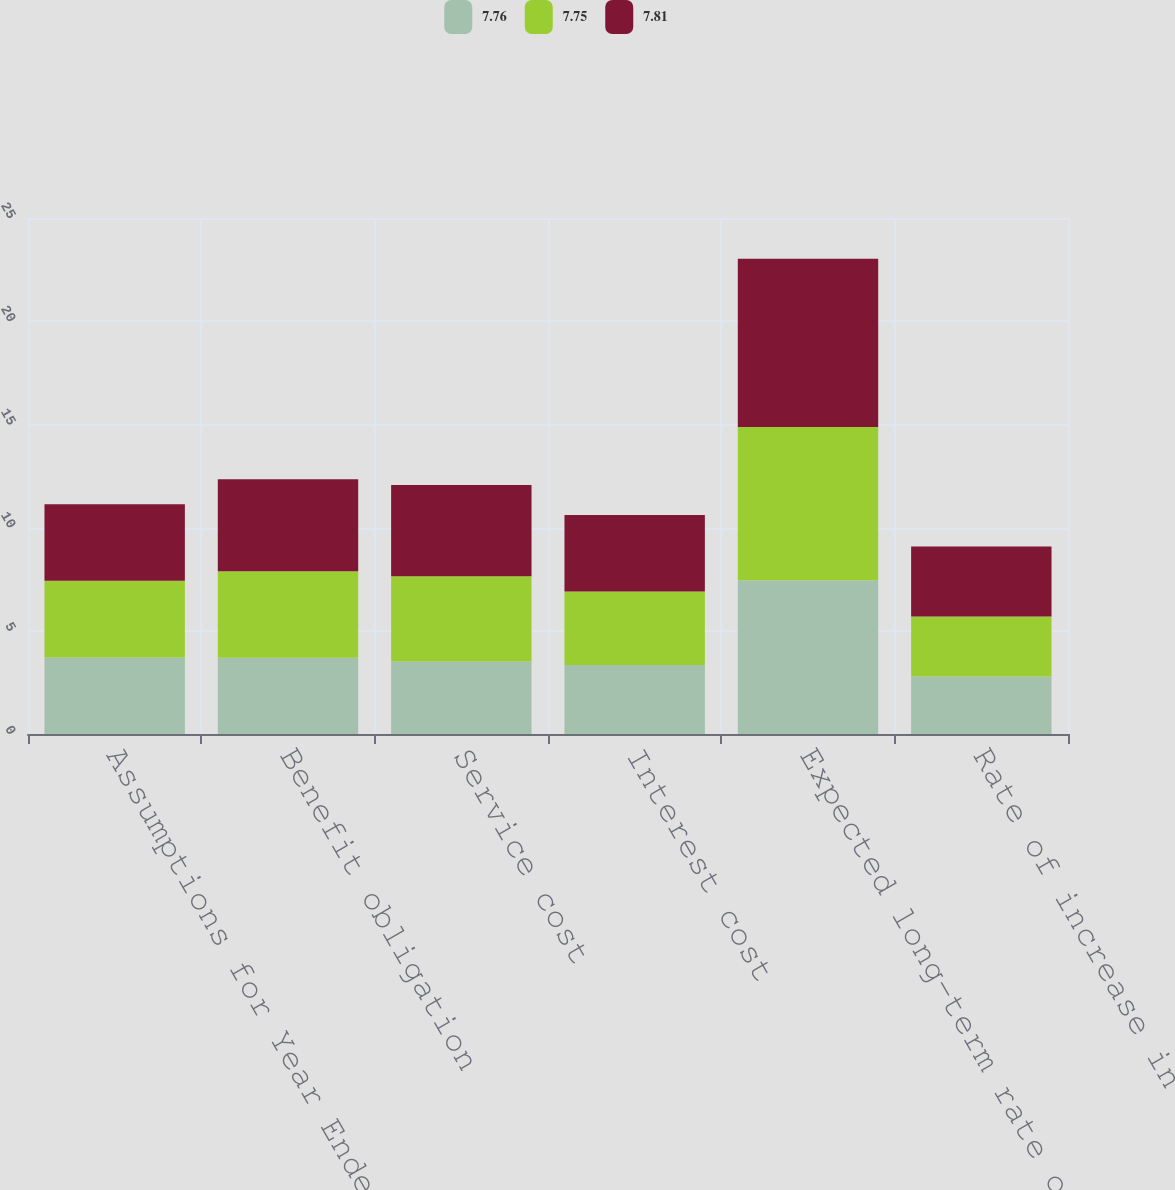<chart> <loc_0><loc_0><loc_500><loc_500><stacked_bar_chart><ecel><fcel>Assumptions for Year Ended<fcel>Benefit obligation<fcel>Service cost<fcel>Interest cost<fcel>Expected long-term rate of<fcel>Rate of increase in<nl><fcel>7.76<fcel>3.71<fcel>3.69<fcel>3.51<fcel>3.34<fcel>7.45<fcel>2.79<nl><fcel>7.75<fcel>3.71<fcel>4.19<fcel>4.13<fcel>3.56<fcel>7.43<fcel>2.9<nl><fcel>7.81<fcel>3.71<fcel>4.46<fcel>4.42<fcel>3.71<fcel>8.14<fcel>3.39<nl></chart> 